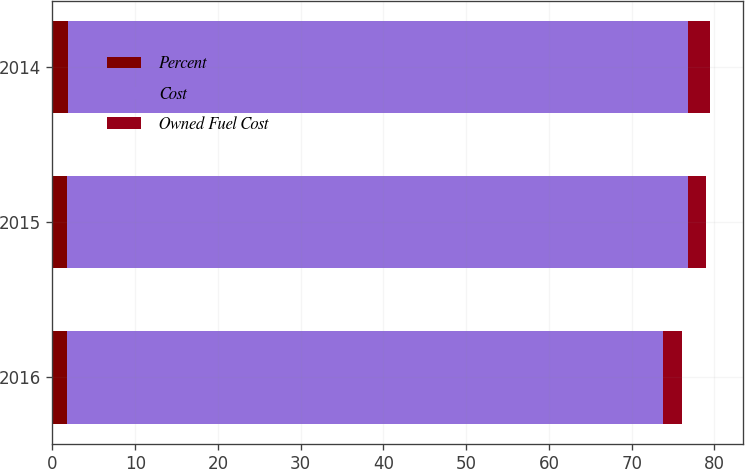Convert chart to OTSL. <chart><loc_0><loc_0><loc_500><loc_500><stacked_bar_chart><ecel><fcel>2016<fcel>2015<fcel>2014<nl><fcel>Percent<fcel>1.75<fcel>1.75<fcel>1.82<nl><fcel>Cost<fcel>72<fcel>75<fcel>75<nl><fcel>Owned Fuel Cost<fcel>2.33<fcel>2.29<fcel>2.68<nl></chart> 